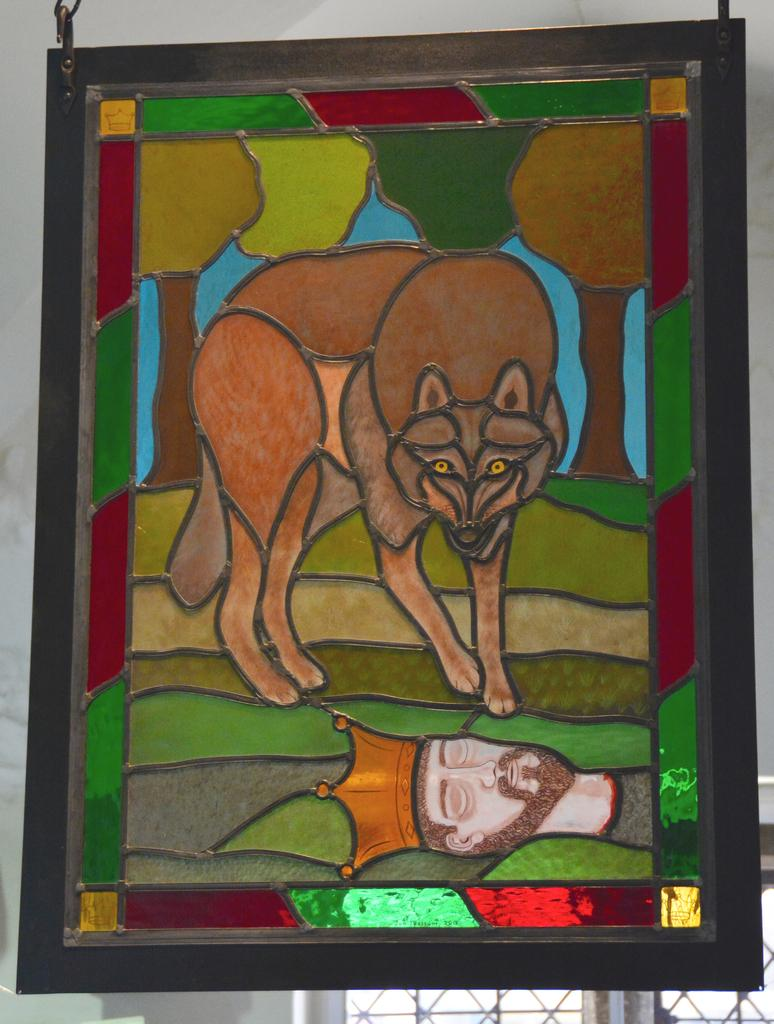What object is the main focus of the image? There is a photo frame in the image. What is depicted inside the photo frame? The photo frame contains a painting of a dog and a person's head. What can be seen in the background of the image? There is a wall in the background of the image. How many visitors are visible in the image? There are no visitors present in the image; it only features a photo frame with a painting. What type of grip does the person in the painting have on the dog? There is no indication of a grip or interaction between the person and the dog in the painting; it only shows a person's head and a dog. 